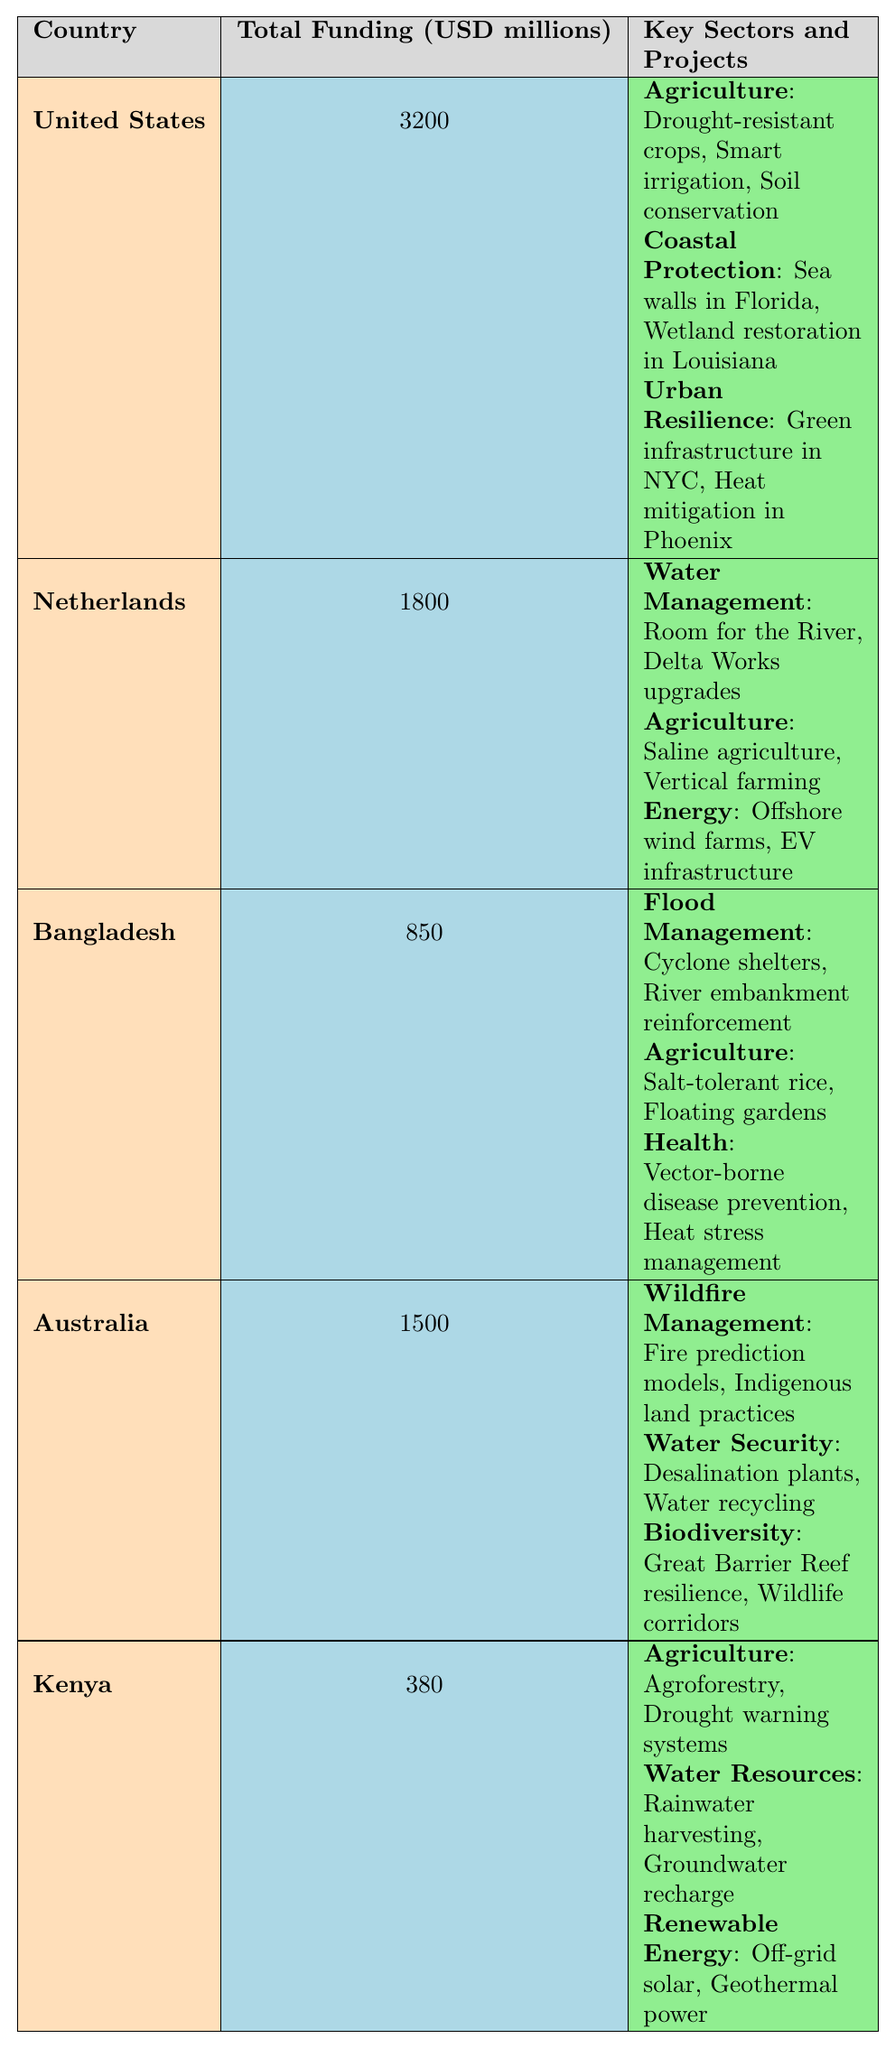What's the total funding for Bangladesh? The table shows that the total funding for Bangladesh is listed as 850 million USD.
Answer: 850 million USD Which country received the highest funding? By comparing the total funding values in the table, the United States has the highest total funding at 3200 million USD.
Answer: United States How much funding is allocated for Urban Resilience in the United States? The table indicates that Urban Resilience in the United States received 1120 million USD.
Answer: 1120 million USD Which sector has the highest funding in the Netherlands? Looking at the sectors under the Netherlands, Water Management received 1200 million USD, which is the highest among the listed sectors.
Answer: Water Management What is the total funding allocated for Agriculture across all countries? Summing the Agriculture funding for each country: 980 (US) + 400 (Netherlands) + 300 (Bangladesh) + 180 (Kenya) = 1860 million USD.
Answer: 1860 million USD Is there funding allocated for Renewable Energy in Kenya? Yes, the table indicates that Kenya has allocated 80 million USD for Renewable Energy.
Answer: Yes How much more funding does the United States receive compared to Bangladesh? The difference between the total funding of the United States (3200 million USD) and Bangladesh (850 million USD) is 3200 - 850 = 2350 million USD.
Answer: 2350 million USD Which country has the least total funding and how much did they receive? According to the table, Kenya has the least total funding with 380 million USD.
Answer: 380 million USD What is the total funding for Water Security projects in Australia? The table specifies that Water Security in Australia received 500 million USD.
Answer: 500 million USD How does the total funding for Flood Management in Bangladesh compare to Agriculture in the same country? Flood Management in Bangladesh received 400 million USD, while Agriculture received 300 million USD. Therefore, Flood Management has 100 million USD more than Agriculture.
Answer: Flood Management has 100 million USD more than Agriculture 